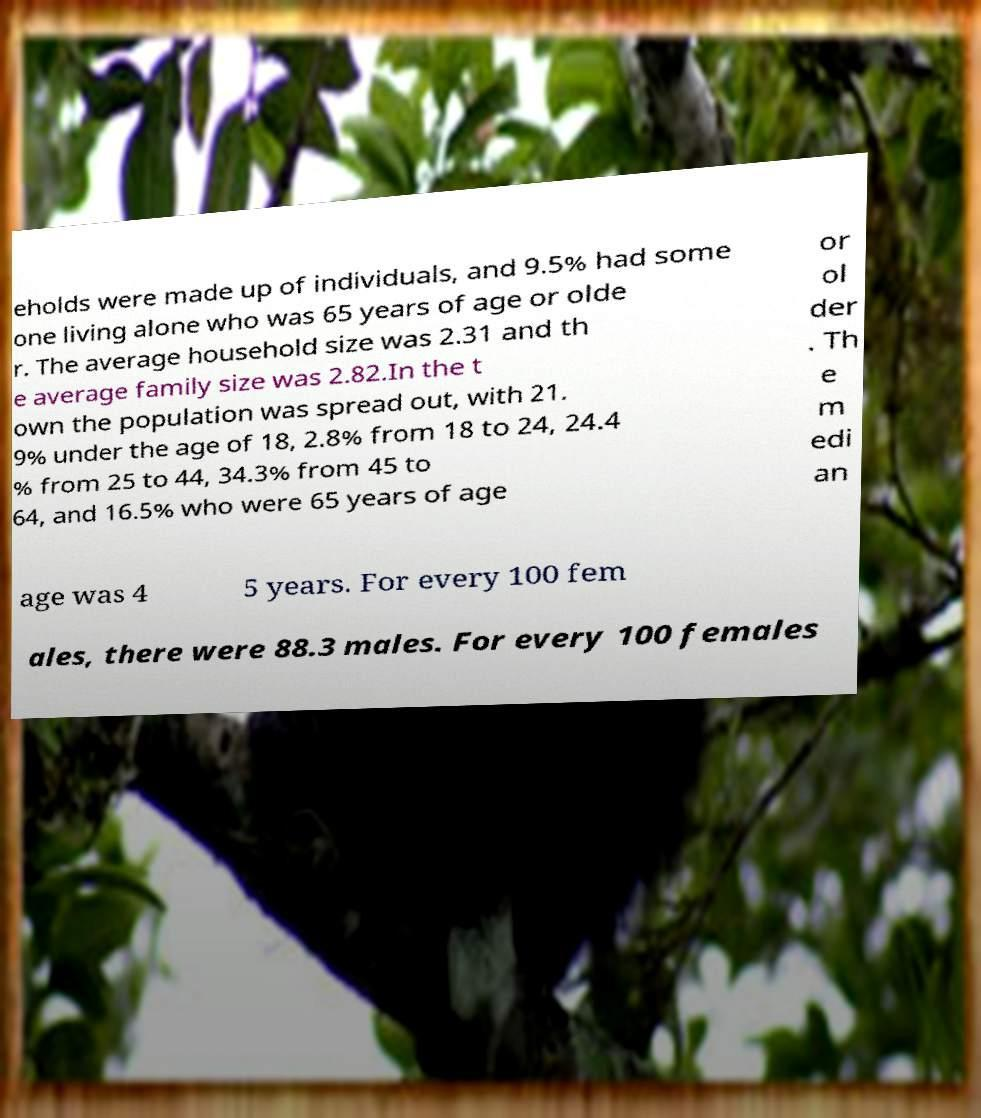There's text embedded in this image that I need extracted. Can you transcribe it verbatim? eholds were made up of individuals, and 9.5% had some one living alone who was 65 years of age or olde r. The average household size was 2.31 and th e average family size was 2.82.In the t own the population was spread out, with 21. 9% under the age of 18, 2.8% from 18 to 24, 24.4 % from 25 to 44, 34.3% from 45 to 64, and 16.5% who were 65 years of age or ol der . Th e m edi an age was 4 5 years. For every 100 fem ales, there were 88.3 males. For every 100 females 